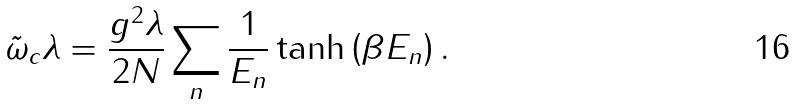Convert formula to latex. <formula><loc_0><loc_0><loc_500><loc_500>\tilde { \omega } _ { c } \lambda = \frac { g ^ { 2 } \lambda } { 2 N } \sum _ { n } \frac { 1 } { E _ { n } } \tanh \left ( \beta E _ { n } \right ) .</formula> 